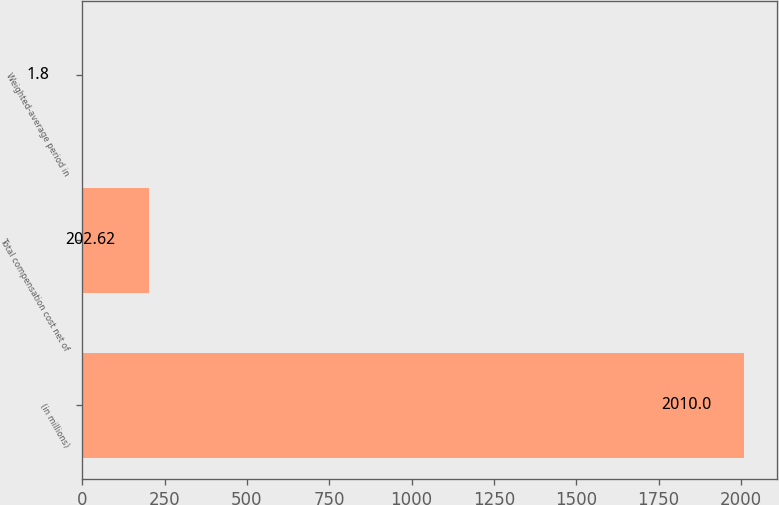Convert chart. <chart><loc_0><loc_0><loc_500><loc_500><bar_chart><fcel>(in millions)<fcel>Total compensation cost net of<fcel>Weighted-average period in<nl><fcel>2010<fcel>202.62<fcel>1.8<nl></chart> 